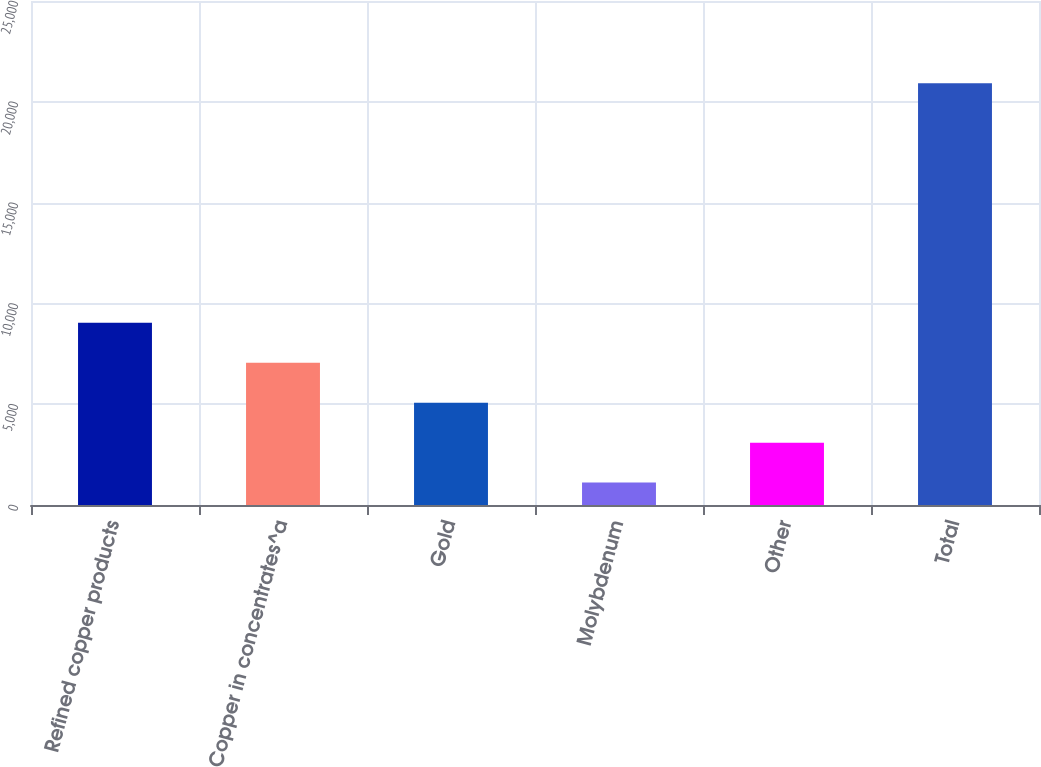<chart> <loc_0><loc_0><loc_500><loc_500><bar_chart><fcel>Refined copper products<fcel>Copper in concentrates^a<fcel>Gold<fcel>Molybdenum<fcel>Other<fcel>Total<nl><fcel>9034.4<fcel>7053.3<fcel>5072.2<fcel>1110<fcel>3091.1<fcel>20921<nl></chart> 